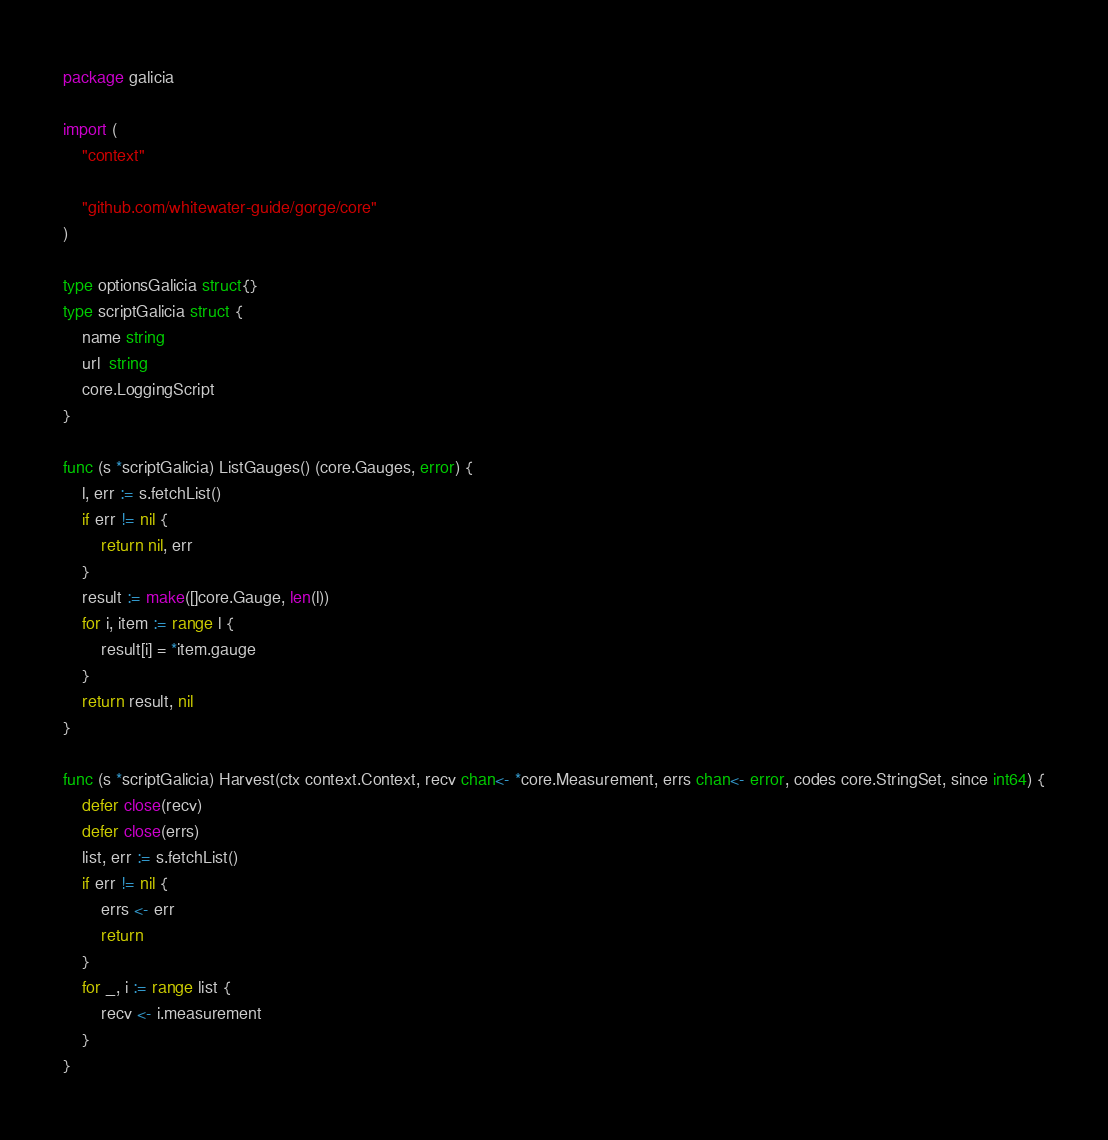<code> <loc_0><loc_0><loc_500><loc_500><_Go_>package galicia

import (
	"context"

	"github.com/whitewater-guide/gorge/core"
)

type optionsGalicia struct{}
type scriptGalicia struct {
	name string
	url  string
	core.LoggingScript
}

func (s *scriptGalicia) ListGauges() (core.Gauges, error) {
	l, err := s.fetchList()
	if err != nil {
		return nil, err
	}
	result := make([]core.Gauge, len(l))
	for i, item := range l {
		result[i] = *item.gauge
	}
	return result, nil
}

func (s *scriptGalicia) Harvest(ctx context.Context, recv chan<- *core.Measurement, errs chan<- error, codes core.StringSet, since int64) {
	defer close(recv)
	defer close(errs)
	list, err := s.fetchList()
	if err != nil {
		errs <- err
		return
	}
	for _, i := range list {
		recv <- i.measurement
	}
}
</code> 